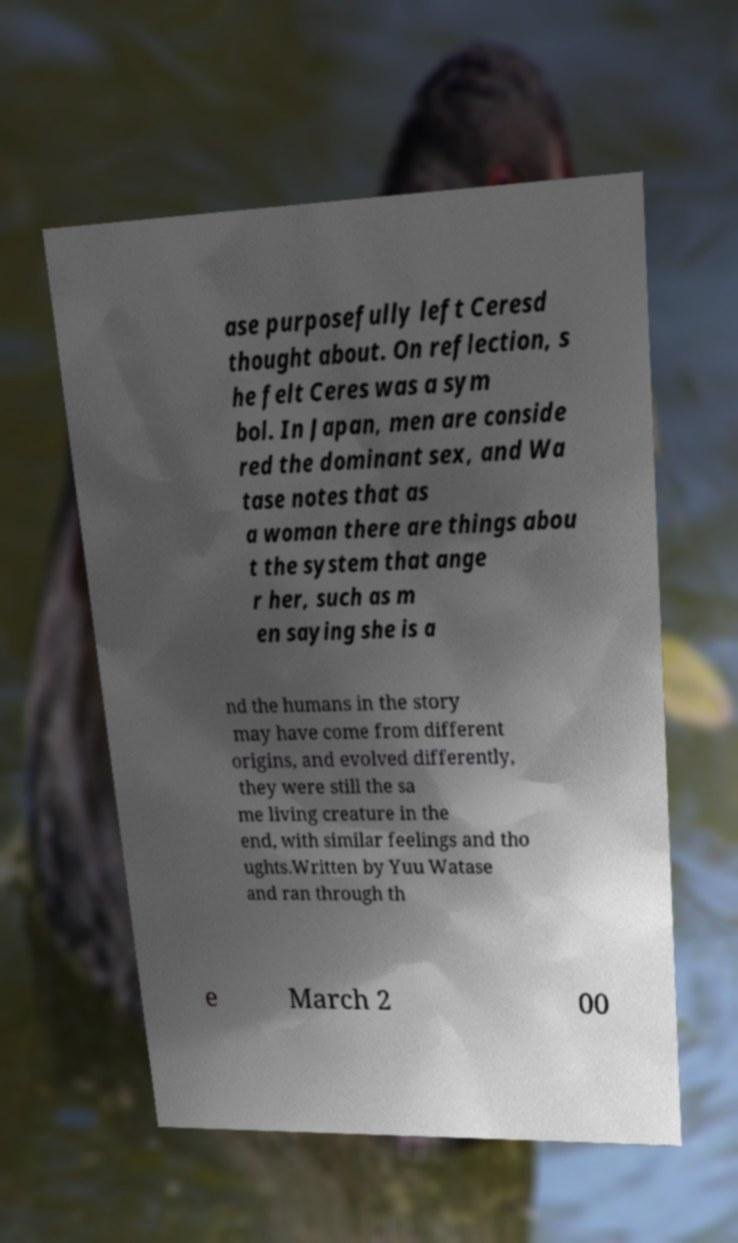Please identify and transcribe the text found in this image. ase purposefully left Ceresd thought about. On reflection, s he felt Ceres was a sym bol. In Japan, men are conside red the dominant sex, and Wa tase notes that as a woman there are things abou t the system that ange r her, such as m en saying she is a nd the humans in the story may have come from different origins, and evolved differently, they were still the sa me living creature in the end, with similar feelings and tho ughts.Written by Yuu Watase and ran through th e March 2 00 